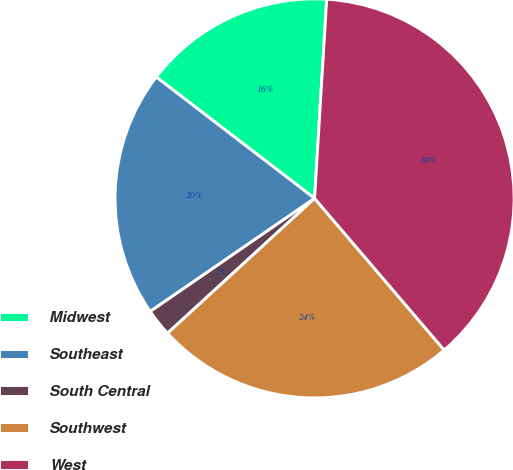Convert chart. <chart><loc_0><loc_0><loc_500><loc_500><pie_chart><fcel>Midwest<fcel>Southeast<fcel>South Central<fcel>Southwest<fcel>West<nl><fcel>15.56%<fcel>20.0%<fcel>2.22%<fcel>24.44%<fcel>37.78%<nl></chart> 